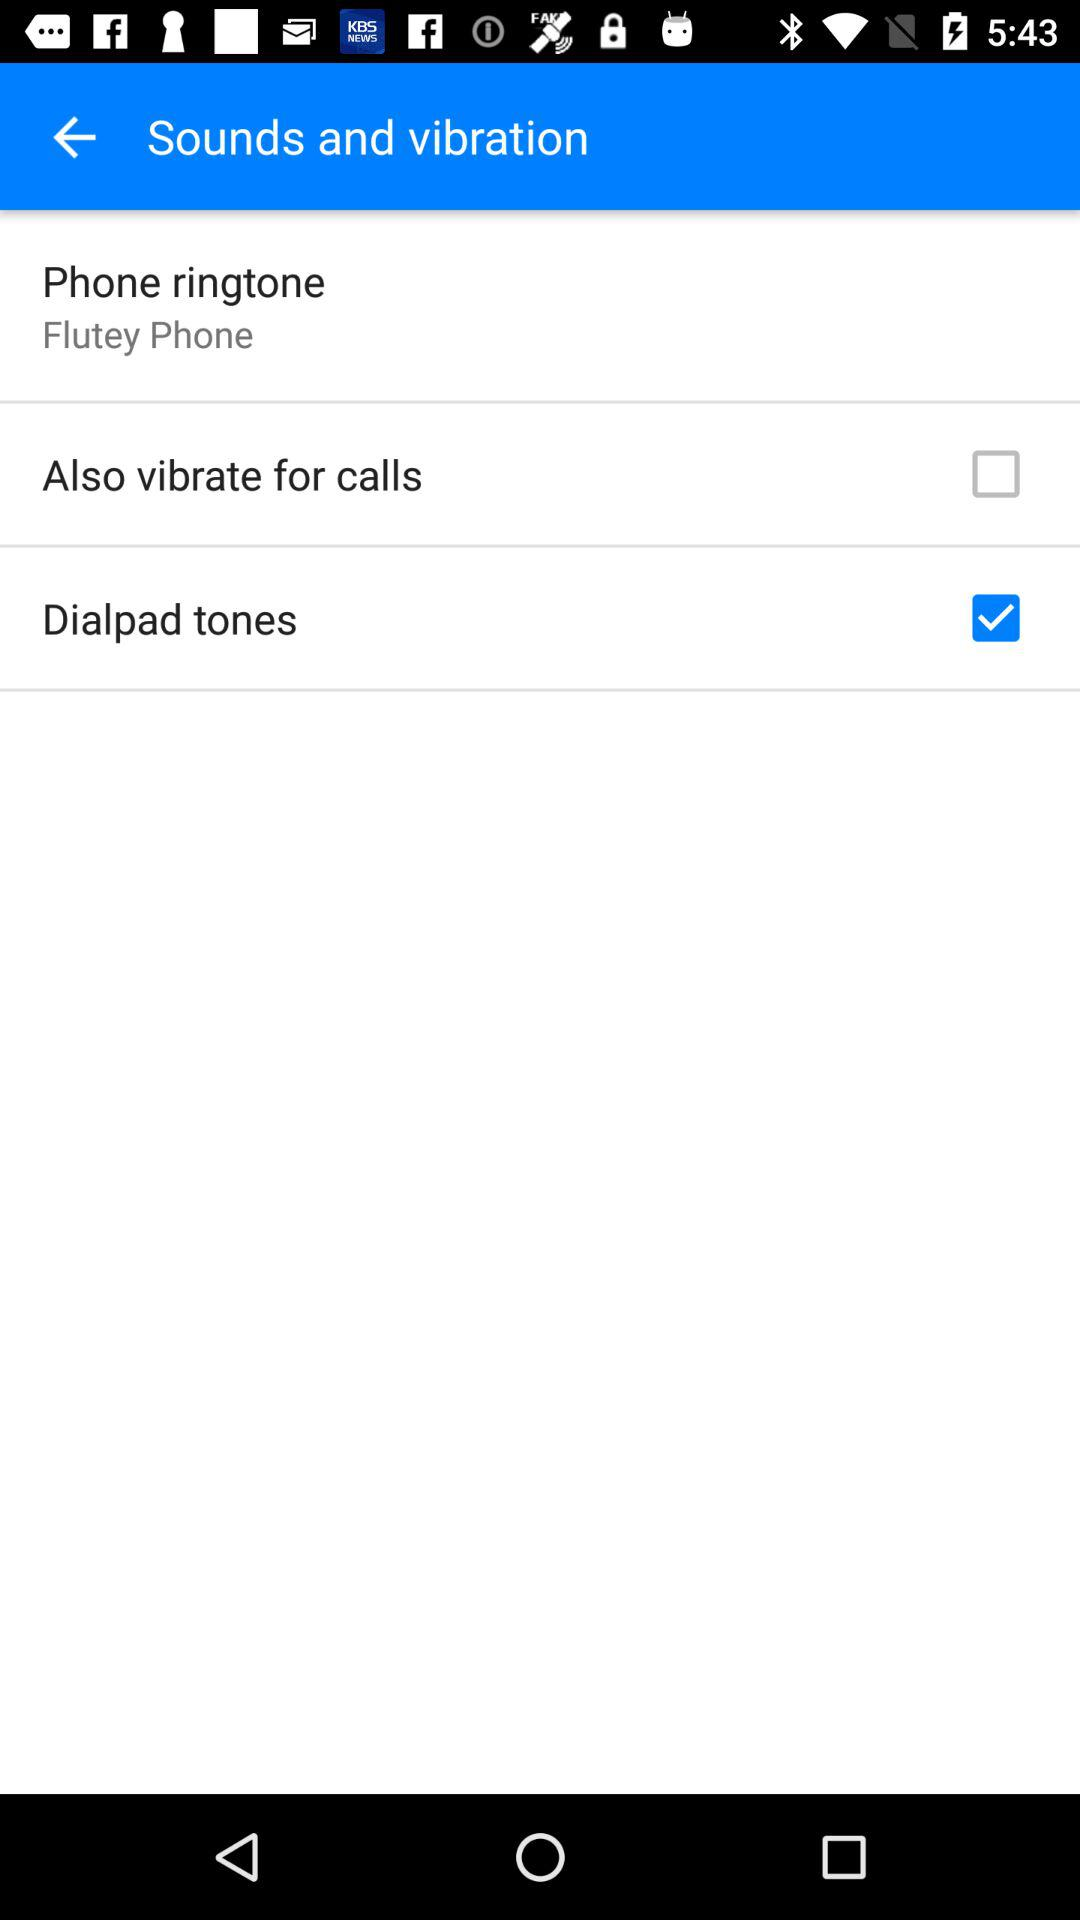How many checkboxes are in the Sounds and vibration section?
Answer the question using a single word or phrase. 2 